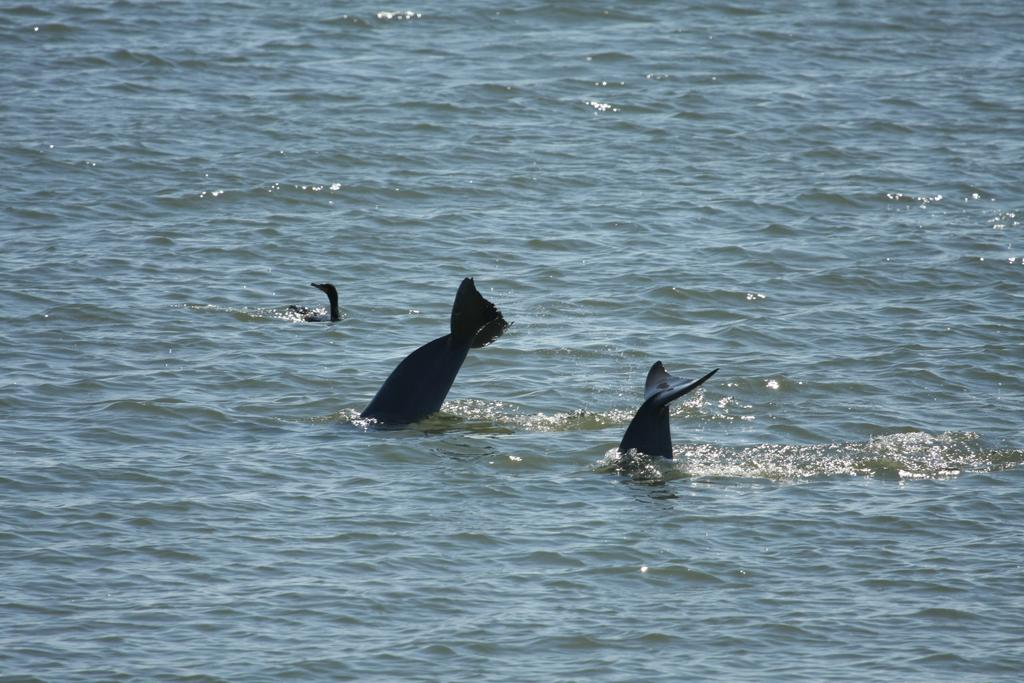What animals can be seen in the image? There are whales in the image. Where are the whales located? The whales are in the water. What language are the whales speaking in the image? Whales do not speak a language, so this cannot be determined from the image. 